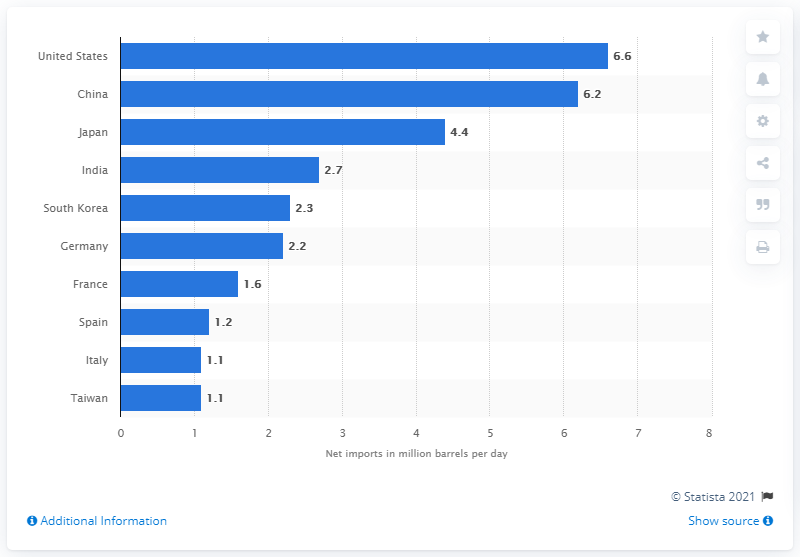Outline some significant characteristics in this image. In 2013, China's net oil imports were 6.2 million barrels per day. 